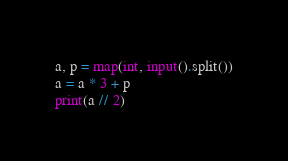Convert code to text. <code><loc_0><loc_0><loc_500><loc_500><_Python_>a, p = map(int, input().split())
a = a * 3 + p
print(a // 2)
</code> 